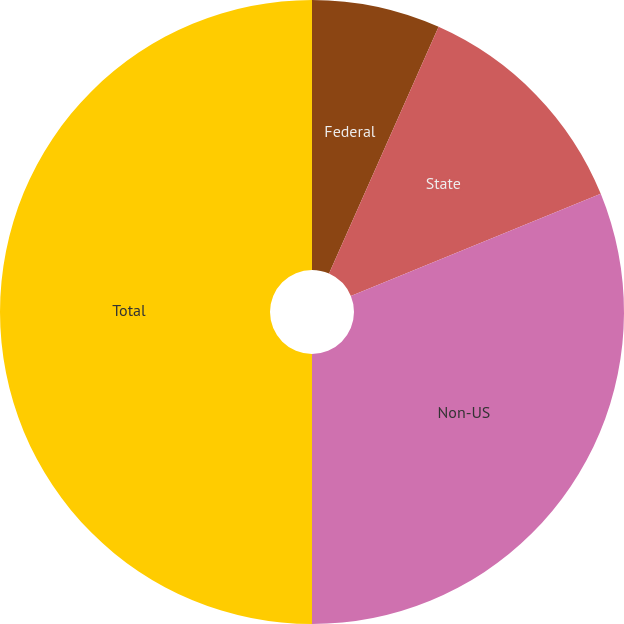<chart> <loc_0><loc_0><loc_500><loc_500><pie_chart><fcel>Federal<fcel>State<fcel>Non-US<fcel>Total<nl><fcel>6.65%<fcel>12.17%<fcel>31.18%<fcel>50.0%<nl></chart> 